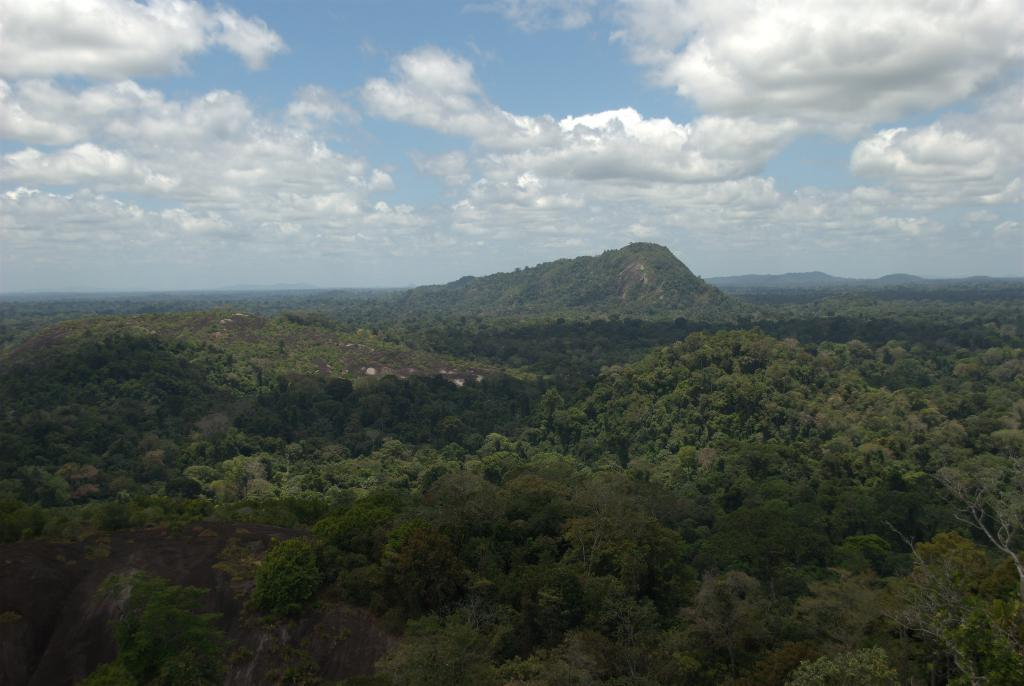What type of vegetation can be seen in the image? There are trees in the image. What color are the trees? The trees are green. What can be seen in the distance behind the trees? There are mountains in the background of the image. What colors are visible in the sky? The sky is blue and white. What type of chairs are visible in the image? There are no chairs present in the image. What is the person writing in the image? There is no person or writing present in the image. 